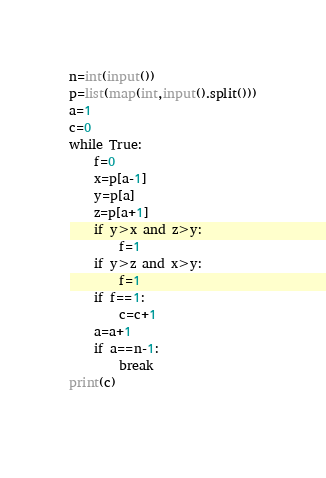Convert code to text. <code><loc_0><loc_0><loc_500><loc_500><_Python_>n=int(input())
p=list(map(int,input().split()))
a=1
c=0
while True:
    f=0
    x=p[a-1]
    y=p[a]
    z=p[a+1]
    if y>x and z>y:
        f=1
    if y>z and x>y:
        f=1
    if f==1:
        c=c+1
    a=a+1
    if a==n-1:
        break
print(c)
    
</code> 